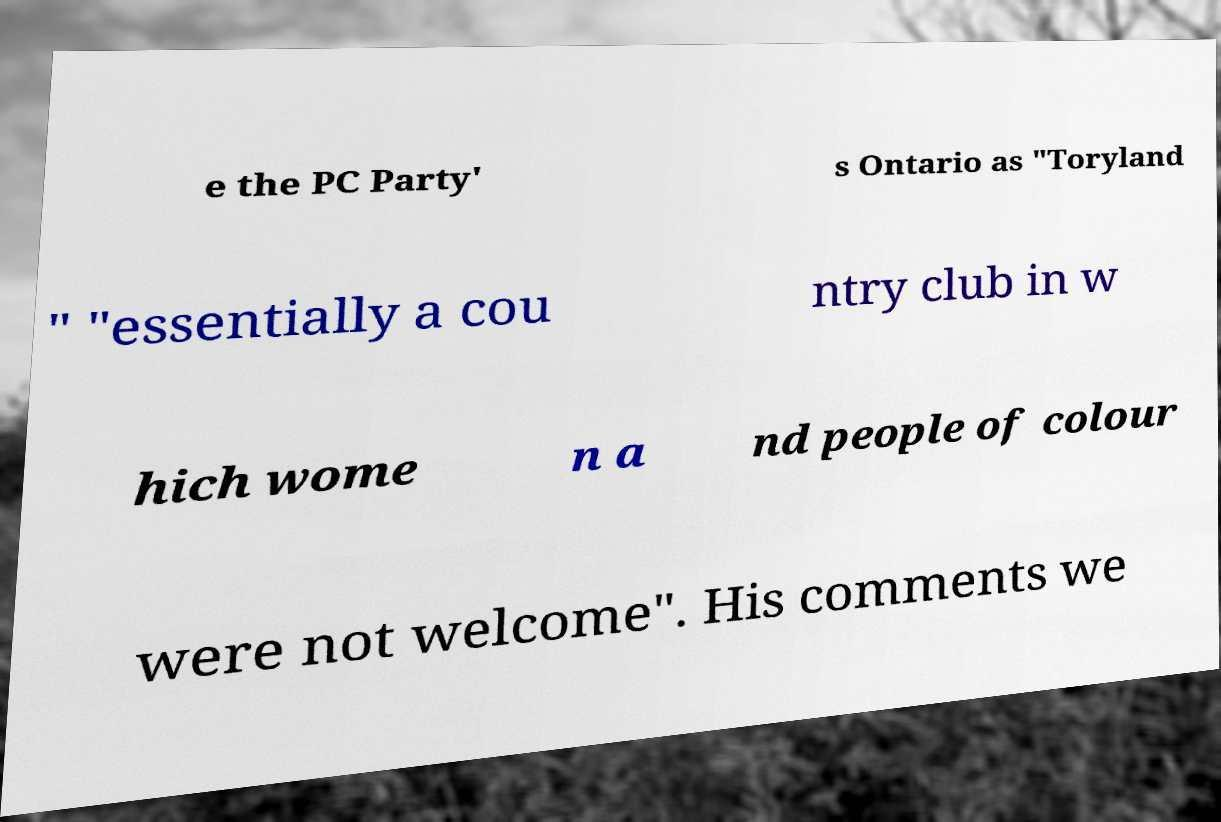I need the written content from this picture converted into text. Can you do that? e the PC Party' s Ontario as "Toryland " "essentially a cou ntry club in w hich wome n a nd people of colour were not welcome". His comments we 